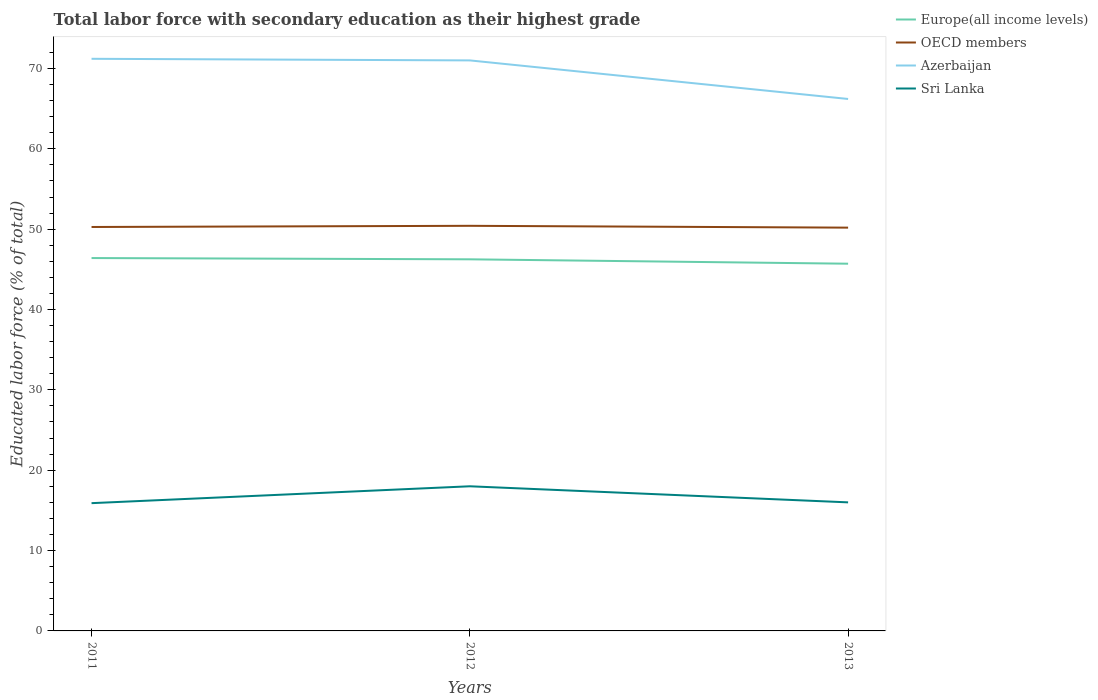How many different coloured lines are there?
Keep it short and to the point. 4. Does the line corresponding to Azerbaijan intersect with the line corresponding to OECD members?
Your answer should be very brief. No. Across all years, what is the maximum percentage of total labor force with primary education in Azerbaijan?
Ensure brevity in your answer.  66.2. What is the total percentage of total labor force with primary education in OECD members in the graph?
Your response must be concise. -0.15. What is the difference between the highest and the second highest percentage of total labor force with primary education in Azerbaijan?
Make the answer very short. 5. What is the difference between the highest and the lowest percentage of total labor force with primary education in Azerbaijan?
Make the answer very short. 2. Is the percentage of total labor force with primary education in OECD members strictly greater than the percentage of total labor force with primary education in Azerbaijan over the years?
Make the answer very short. Yes. How many years are there in the graph?
Offer a terse response. 3. Does the graph contain any zero values?
Keep it short and to the point. No. Does the graph contain grids?
Your response must be concise. No. How are the legend labels stacked?
Your response must be concise. Vertical. What is the title of the graph?
Ensure brevity in your answer.  Total labor force with secondary education as their highest grade. Does "Kyrgyz Republic" appear as one of the legend labels in the graph?
Keep it short and to the point. No. What is the label or title of the Y-axis?
Provide a short and direct response. Educated labor force (% of total). What is the Educated labor force (% of total) of Europe(all income levels) in 2011?
Keep it short and to the point. 46.4. What is the Educated labor force (% of total) of OECD members in 2011?
Make the answer very short. 50.27. What is the Educated labor force (% of total) in Azerbaijan in 2011?
Your answer should be very brief. 71.2. What is the Educated labor force (% of total) in Sri Lanka in 2011?
Provide a succinct answer. 15.9. What is the Educated labor force (% of total) in Europe(all income levels) in 2012?
Offer a terse response. 46.25. What is the Educated labor force (% of total) of OECD members in 2012?
Your answer should be very brief. 50.41. What is the Educated labor force (% of total) of Azerbaijan in 2012?
Offer a terse response. 71. What is the Educated labor force (% of total) in Sri Lanka in 2012?
Your answer should be compact. 18. What is the Educated labor force (% of total) of Europe(all income levels) in 2013?
Offer a terse response. 45.7. What is the Educated labor force (% of total) of OECD members in 2013?
Your response must be concise. 50.19. What is the Educated labor force (% of total) of Azerbaijan in 2013?
Ensure brevity in your answer.  66.2. Across all years, what is the maximum Educated labor force (% of total) in Europe(all income levels)?
Make the answer very short. 46.4. Across all years, what is the maximum Educated labor force (% of total) in OECD members?
Your answer should be compact. 50.41. Across all years, what is the maximum Educated labor force (% of total) in Azerbaijan?
Keep it short and to the point. 71.2. Across all years, what is the minimum Educated labor force (% of total) in Europe(all income levels)?
Provide a short and direct response. 45.7. Across all years, what is the minimum Educated labor force (% of total) in OECD members?
Ensure brevity in your answer.  50.19. Across all years, what is the minimum Educated labor force (% of total) in Azerbaijan?
Keep it short and to the point. 66.2. Across all years, what is the minimum Educated labor force (% of total) in Sri Lanka?
Offer a very short reply. 15.9. What is the total Educated labor force (% of total) of Europe(all income levels) in the graph?
Your answer should be compact. 138.35. What is the total Educated labor force (% of total) in OECD members in the graph?
Your response must be concise. 150.87. What is the total Educated labor force (% of total) of Azerbaijan in the graph?
Your answer should be compact. 208.4. What is the total Educated labor force (% of total) of Sri Lanka in the graph?
Your answer should be very brief. 49.9. What is the difference between the Educated labor force (% of total) in Europe(all income levels) in 2011 and that in 2012?
Your answer should be compact. 0.16. What is the difference between the Educated labor force (% of total) in OECD members in 2011 and that in 2012?
Offer a very short reply. -0.15. What is the difference between the Educated labor force (% of total) of Europe(all income levels) in 2011 and that in 2013?
Offer a very short reply. 0.7. What is the difference between the Educated labor force (% of total) of OECD members in 2011 and that in 2013?
Keep it short and to the point. 0.08. What is the difference between the Educated labor force (% of total) of Azerbaijan in 2011 and that in 2013?
Offer a terse response. 5. What is the difference between the Educated labor force (% of total) of Sri Lanka in 2011 and that in 2013?
Your response must be concise. -0.1. What is the difference between the Educated labor force (% of total) in Europe(all income levels) in 2012 and that in 2013?
Provide a short and direct response. 0.55. What is the difference between the Educated labor force (% of total) in OECD members in 2012 and that in 2013?
Offer a very short reply. 0.23. What is the difference between the Educated labor force (% of total) in Azerbaijan in 2012 and that in 2013?
Provide a succinct answer. 4.8. What is the difference between the Educated labor force (% of total) in Sri Lanka in 2012 and that in 2013?
Your answer should be compact. 2. What is the difference between the Educated labor force (% of total) of Europe(all income levels) in 2011 and the Educated labor force (% of total) of OECD members in 2012?
Ensure brevity in your answer.  -4.01. What is the difference between the Educated labor force (% of total) of Europe(all income levels) in 2011 and the Educated labor force (% of total) of Azerbaijan in 2012?
Give a very brief answer. -24.6. What is the difference between the Educated labor force (% of total) in Europe(all income levels) in 2011 and the Educated labor force (% of total) in Sri Lanka in 2012?
Provide a succinct answer. 28.4. What is the difference between the Educated labor force (% of total) of OECD members in 2011 and the Educated labor force (% of total) of Azerbaijan in 2012?
Give a very brief answer. -20.73. What is the difference between the Educated labor force (% of total) of OECD members in 2011 and the Educated labor force (% of total) of Sri Lanka in 2012?
Give a very brief answer. 32.27. What is the difference between the Educated labor force (% of total) of Azerbaijan in 2011 and the Educated labor force (% of total) of Sri Lanka in 2012?
Provide a succinct answer. 53.2. What is the difference between the Educated labor force (% of total) of Europe(all income levels) in 2011 and the Educated labor force (% of total) of OECD members in 2013?
Your response must be concise. -3.78. What is the difference between the Educated labor force (% of total) of Europe(all income levels) in 2011 and the Educated labor force (% of total) of Azerbaijan in 2013?
Provide a short and direct response. -19.8. What is the difference between the Educated labor force (% of total) in Europe(all income levels) in 2011 and the Educated labor force (% of total) in Sri Lanka in 2013?
Your answer should be compact. 30.4. What is the difference between the Educated labor force (% of total) in OECD members in 2011 and the Educated labor force (% of total) in Azerbaijan in 2013?
Provide a short and direct response. -15.93. What is the difference between the Educated labor force (% of total) in OECD members in 2011 and the Educated labor force (% of total) in Sri Lanka in 2013?
Keep it short and to the point. 34.27. What is the difference between the Educated labor force (% of total) of Azerbaijan in 2011 and the Educated labor force (% of total) of Sri Lanka in 2013?
Your answer should be compact. 55.2. What is the difference between the Educated labor force (% of total) in Europe(all income levels) in 2012 and the Educated labor force (% of total) in OECD members in 2013?
Your response must be concise. -3.94. What is the difference between the Educated labor force (% of total) in Europe(all income levels) in 2012 and the Educated labor force (% of total) in Azerbaijan in 2013?
Offer a terse response. -19.95. What is the difference between the Educated labor force (% of total) in Europe(all income levels) in 2012 and the Educated labor force (% of total) in Sri Lanka in 2013?
Provide a short and direct response. 30.25. What is the difference between the Educated labor force (% of total) in OECD members in 2012 and the Educated labor force (% of total) in Azerbaijan in 2013?
Keep it short and to the point. -15.79. What is the difference between the Educated labor force (% of total) in OECD members in 2012 and the Educated labor force (% of total) in Sri Lanka in 2013?
Ensure brevity in your answer.  34.41. What is the difference between the Educated labor force (% of total) in Azerbaijan in 2012 and the Educated labor force (% of total) in Sri Lanka in 2013?
Your response must be concise. 55. What is the average Educated labor force (% of total) in Europe(all income levels) per year?
Provide a succinct answer. 46.12. What is the average Educated labor force (% of total) in OECD members per year?
Your answer should be very brief. 50.29. What is the average Educated labor force (% of total) of Azerbaijan per year?
Your response must be concise. 69.47. What is the average Educated labor force (% of total) in Sri Lanka per year?
Offer a very short reply. 16.63. In the year 2011, what is the difference between the Educated labor force (% of total) in Europe(all income levels) and Educated labor force (% of total) in OECD members?
Make the answer very short. -3.87. In the year 2011, what is the difference between the Educated labor force (% of total) in Europe(all income levels) and Educated labor force (% of total) in Azerbaijan?
Your answer should be compact. -24.8. In the year 2011, what is the difference between the Educated labor force (% of total) in Europe(all income levels) and Educated labor force (% of total) in Sri Lanka?
Keep it short and to the point. 30.5. In the year 2011, what is the difference between the Educated labor force (% of total) of OECD members and Educated labor force (% of total) of Azerbaijan?
Provide a succinct answer. -20.93. In the year 2011, what is the difference between the Educated labor force (% of total) in OECD members and Educated labor force (% of total) in Sri Lanka?
Give a very brief answer. 34.37. In the year 2011, what is the difference between the Educated labor force (% of total) in Azerbaijan and Educated labor force (% of total) in Sri Lanka?
Give a very brief answer. 55.3. In the year 2012, what is the difference between the Educated labor force (% of total) in Europe(all income levels) and Educated labor force (% of total) in OECD members?
Provide a succinct answer. -4.17. In the year 2012, what is the difference between the Educated labor force (% of total) in Europe(all income levels) and Educated labor force (% of total) in Azerbaijan?
Give a very brief answer. -24.75. In the year 2012, what is the difference between the Educated labor force (% of total) in Europe(all income levels) and Educated labor force (% of total) in Sri Lanka?
Give a very brief answer. 28.25. In the year 2012, what is the difference between the Educated labor force (% of total) in OECD members and Educated labor force (% of total) in Azerbaijan?
Offer a very short reply. -20.59. In the year 2012, what is the difference between the Educated labor force (% of total) in OECD members and Educated labor force (% of total) in Sri Lanka?
Your response must be concise. 32.41. In the year 2012, what is the difference between the Educated labor force (% of total) in Azerbaijan and Educated labor force (% of total) in Sri Lanka?
Provide a short and direct response. 53. In the year 2013, what is the difference between the Educated labor force (% of total) in Europe(all income levels) and Educated labor force (% of total) in OECD members?
Offer a terse response. -4.49. In the year 2013, what is the difference between the Educated labor force (% of total) of Europe(all income levels) and Educated labor force (% of total) of Azerbaijan?
Provide a short and direct response. -20.5. In the year 2013, what is the difference between the Educated labor force (% of total) in Europe(all income levels) and Educated labor force (% of total) in Sri Lanka?
Your answer should be very brief. 29.7. In the year 2013, what is the difference between the Educated labor force (% of total) of OECD members and Educated labor force (% of total) of Azerbaijan?
Give a very brief answer. -16.01. In the year 2013, what is the difference between the Educated labor force (% of total) in OECD members and Educated labor force (% of total) in Sri Lanka?
Your answer should be very brief. 34.19. In the year 2013, what is the difference between the Educated labor force (% of total) of Azerbaijan and Educated labor force (% of total) of Sri Lanka?
Offer a terse response. 50.2. What is the ratio of the Educated labor force (% of total) in Europe(all income levels) in 2011 to that in 2012?
Give a very brief answer. 1. What is the ratio of the Educated labor force (% of total) in OECD members in 2011 to that in 2012?
Provide a succinct answer. 1. What is the ratio of the Educated labor force (% of total) of Azerbaijan in 2011 to that in 2012?
Your answer should be very brief. 1. What is the ratio of the Educated labor force (% of total) in Sri Lanka in 2011 to that in 2012?
Your response must be concise. 0.88. What is the ratio of the Educated labor force (% of total) of Europe(all income levels) in 2011 to that in 2013?
Give a very brief answer. 1.02. What is the ratio of the Educated labor force (% of total) in Azerbaijan in 2011 to that in 2013?
Make the answer very short. 1.08. What is the ratio of the Educated labor force (% of total) of Sri Lanka in 2011 to that in 2013?
Your answer should be compact. 0.99. What is the ratio of the Educated labor force (% of total) of Azerbaijan in 2012 to that in 2013?
Offer a very short reply. 1.07. What is the difference between the highest and the second highest Educated labor force (% of total) of Europe(all income levels)?
Your answer should be very brief. 0.16. What is the difference between the highest and the second highest Educated labor force (% of total) in OECD members?
Your response must be concise. 0.15. What is the difference between the highest and the second highest Educated labor force (% of total) in Azerbaijan?
Offer a terse response. 0.2. What is the difference between the highest and the lowest Educated labor force (% of total) of Europe(all income levels)?
Your answer should be compact. 0.7. What is the difference between the highest and the lowest Educated labor force (% of total) in OECD members?
Offer a very short reply. 0.23. What is the difference between the highest and the lowest Educated labor force (% of total) in Azerbaijan?
Make the answer very short. 5. 